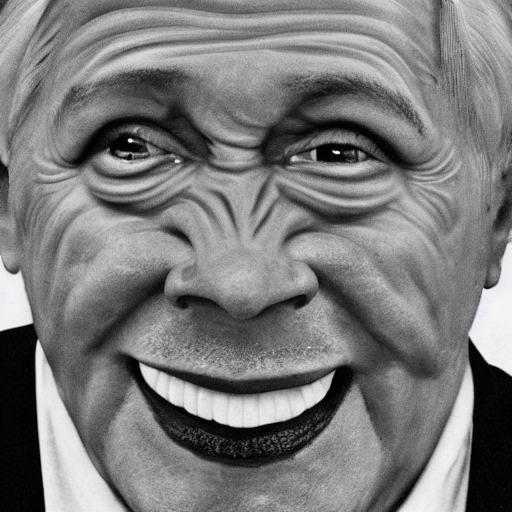Can you discuss the photographic style used in this portrait? Certainly. This portrait features a high-contrast monochromatic color scheme, with the subject's features sharply defined against a solid background. The close-up angle highlights the textures and lines of the face, which are accentuated by the black-and-white filter to create a striking and dramatic effect. 